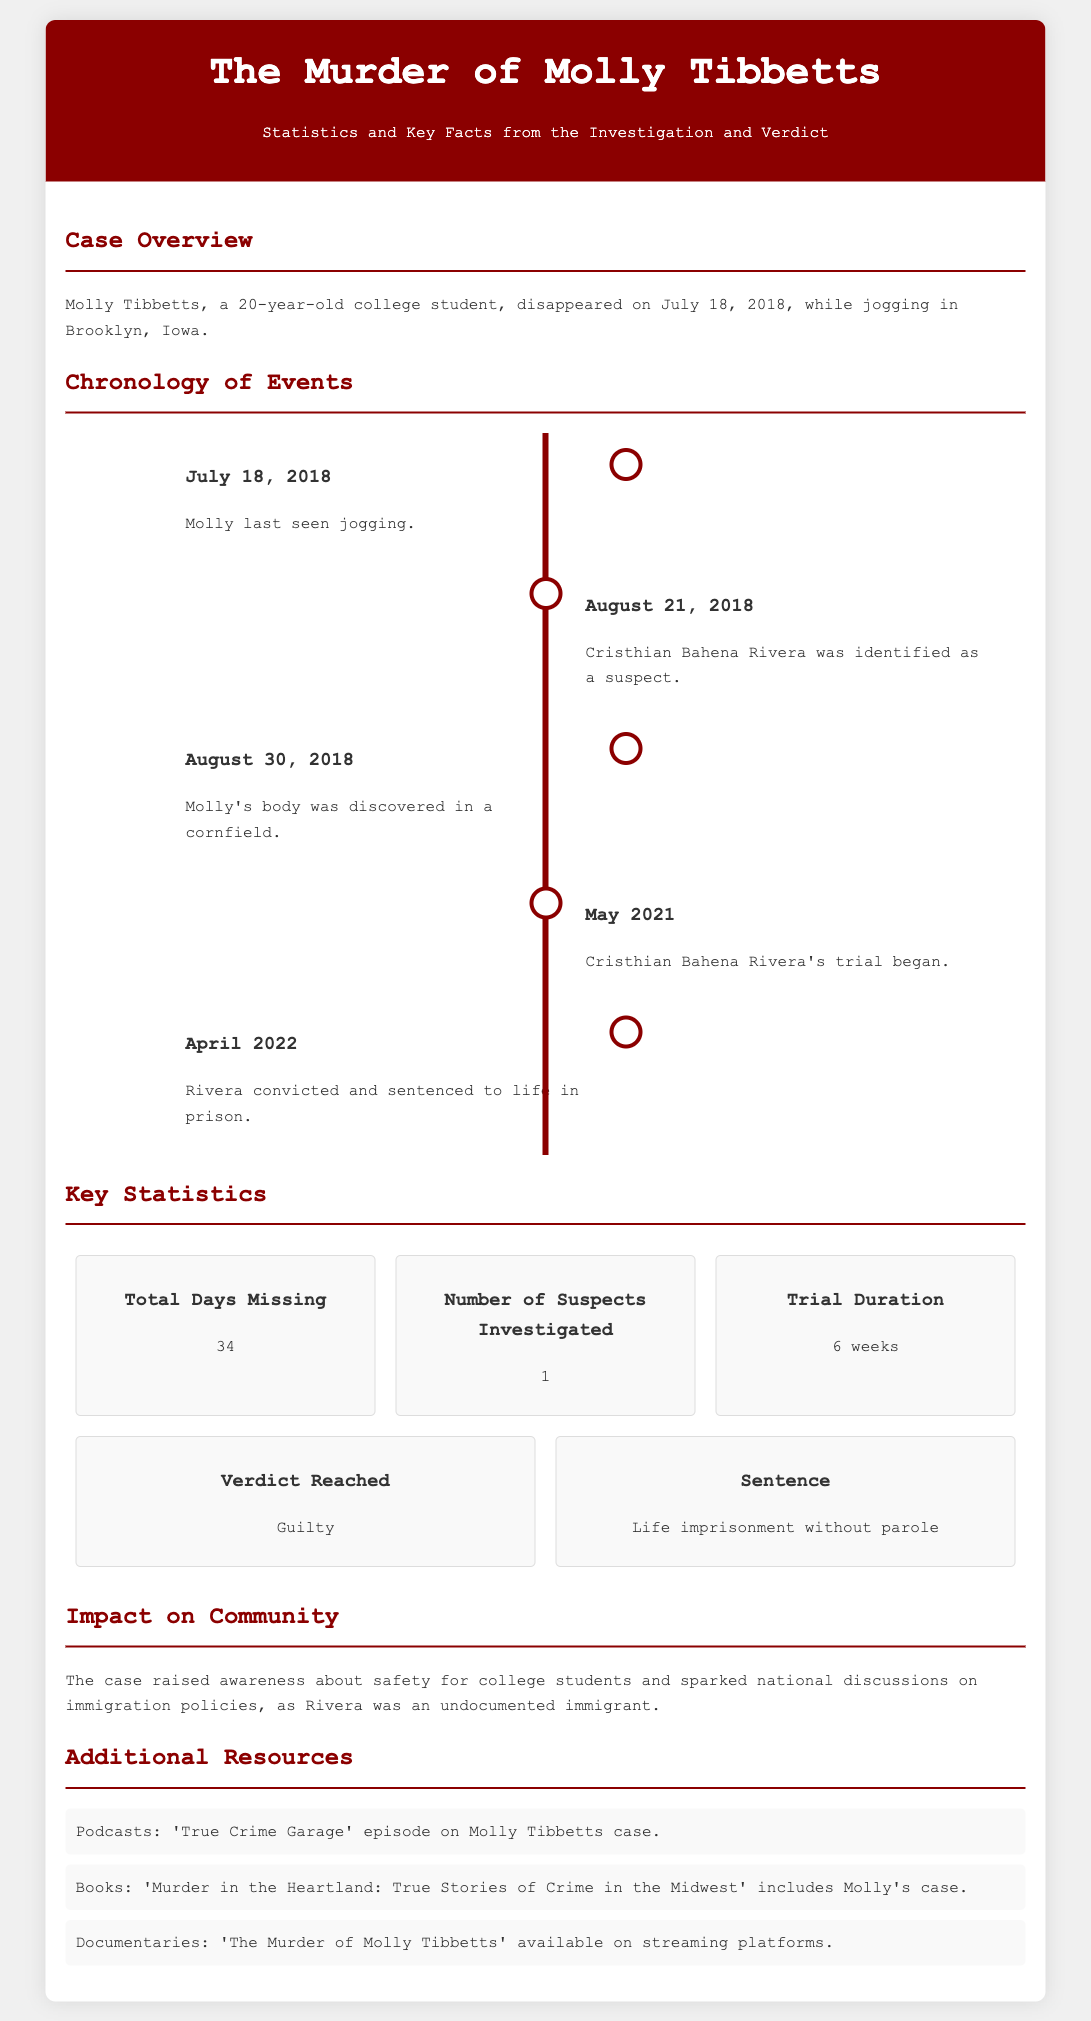What date did Molly Tibbetts disappear? Molly Tibbetts disappeared on July 18, 2018, as stated in the case overview.
Answer: July 18, 2018 Who was identified as a suspect in the case? The suspect identified in the case was Cristhian Bahena Rivera.
Answer: Cristhian Bahena Rivera How many days was Molly Tibbetts missing? The total days Molly Tibbetts was missing is mentioned in the statistics section as 34 days.
Answer: 34 What was the verdict reached in the trial? The verdict reached in the trial, as noted in the key statistics section, was guilty.
Answer: Guilty What was the sentence given to Cristhian Bahena Rivera? The sentence given was life imprisonment without parole, according to the key statistics section.
Answer: Life imprisonment without parole What event took place on August 30, 2018? Molly's body was discovered in a cornfield, marking a significant milestone in the chronology of events.
Answer: Molly's body was discovered in a cornfield How long did the trial last? The trial duration is provided as 6 weeks in the statistics area.
Answer: 6 weeks What sparked national discussions after the case? The case sparked national discussions on immigration policies as highlighted in the impact section.
Answer: Immigration policies How many suspects were investigated in total? The number of suspects investigated is noted as 1 in the key statistics section.
Answer: 1 